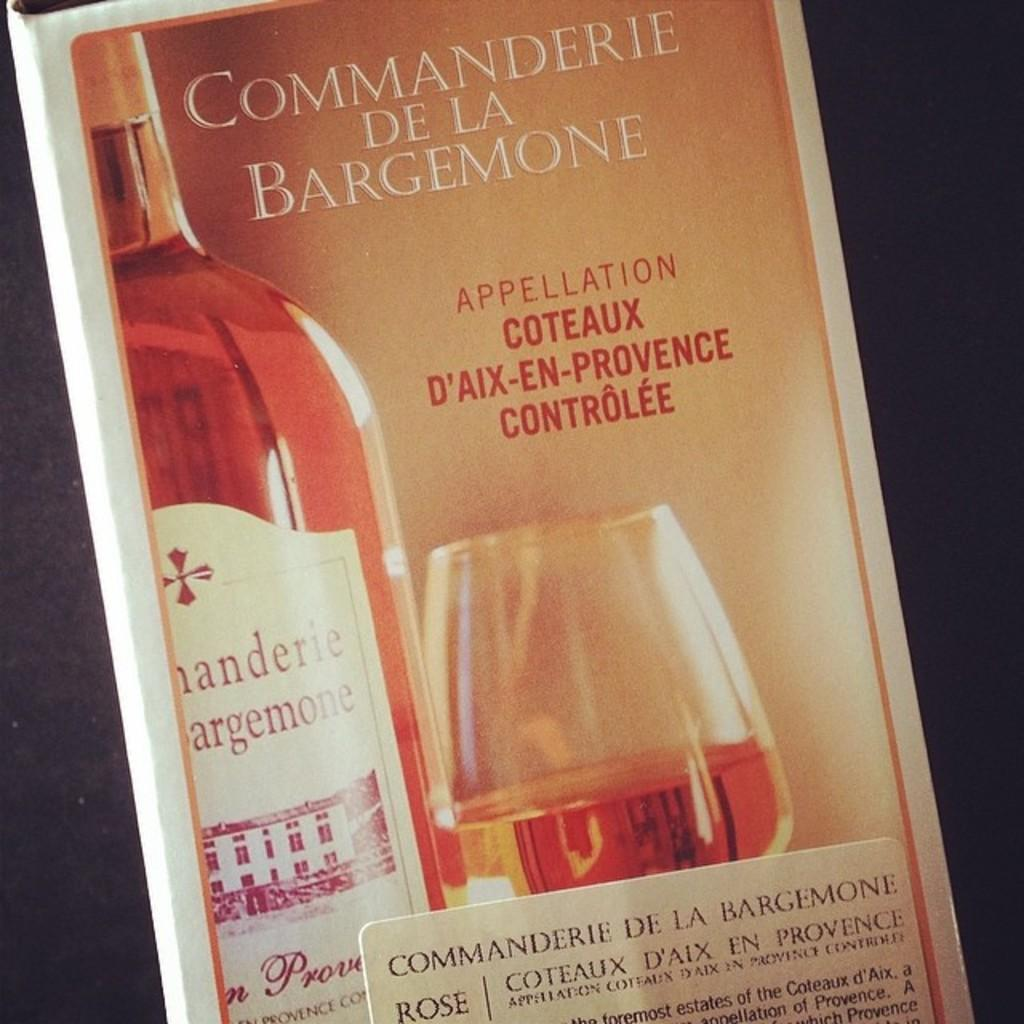<image>
Provide a brief description of the given image. A box that reads Manderie de la Gemone. 